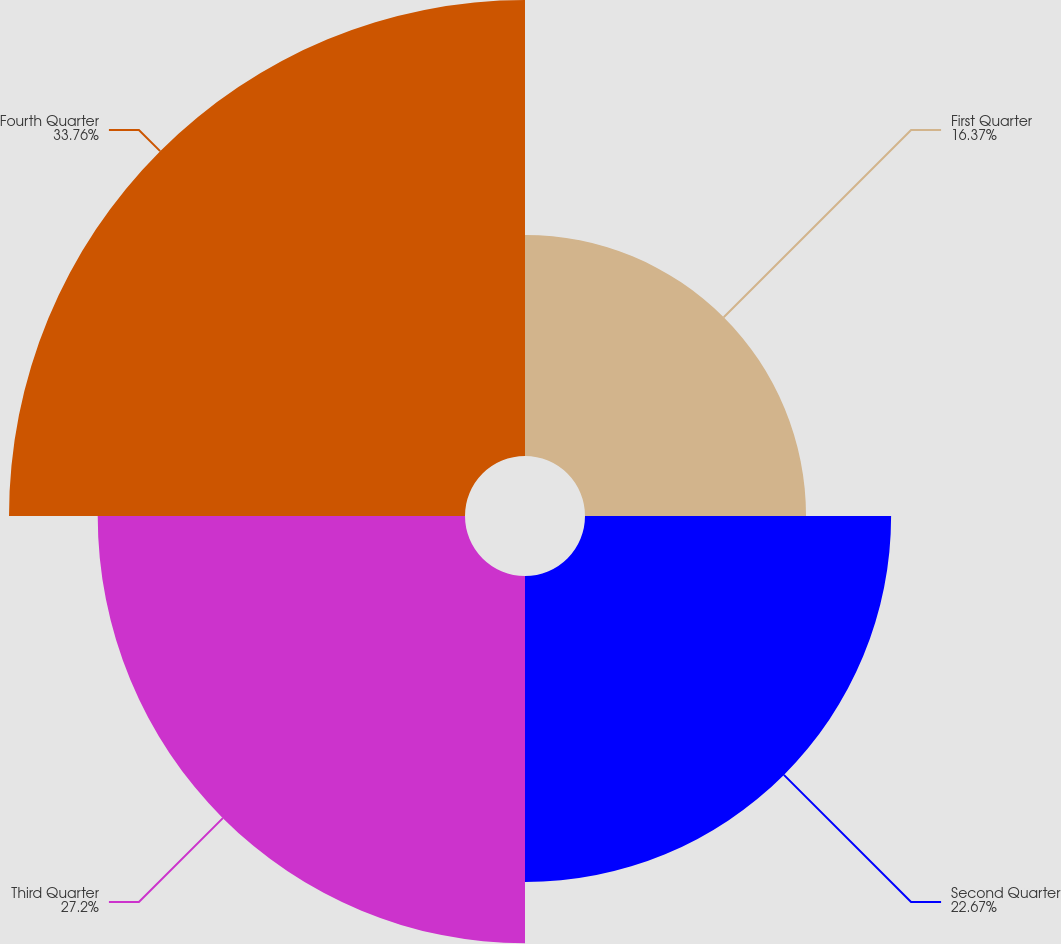<chart> <loc_0><loc_0><loc_500><loc_500><pie_chart><fcel>First Quarter<fcel>Second Quarter<fcel>Third Quarter<fcel>Fourth Quarter<nl><fcel>16.37%<fcel>22.67%<fcel>27.2%<fcel>33.77%<nl></chart> 